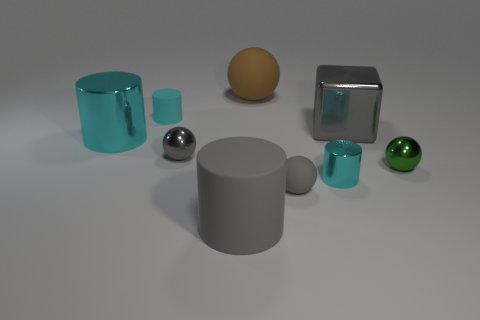Subtract all red blocks. How many cyan cylinders are left? 3 Add 1 tiny brown matte cubes. How many objects exist? 10 Subtract all cubes. How many objects are left? 8 Add 8 small metallic cylinders. How many small metallic cylinders are left? 9 Add 6 tiny cyan metallic cylinders. How many tiny cyan metallic cylinders exist? 7 Subtract 0 cyan blocks. How many objects are left? 9 Subtract all tiny green shiny things. Subtract all big metal cylinders. How many objects are left? 7 